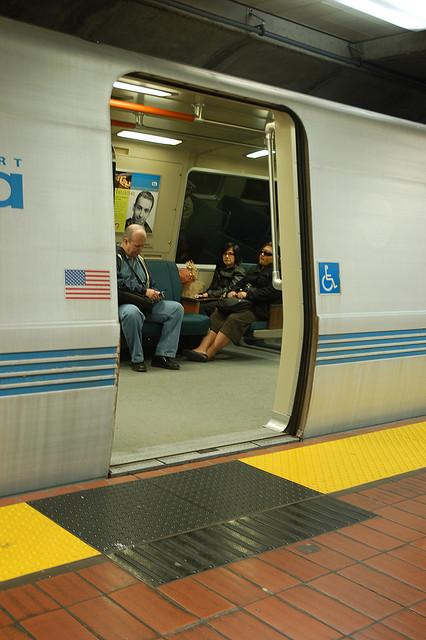What has the train indicated it is accessible to? wheelchairs 